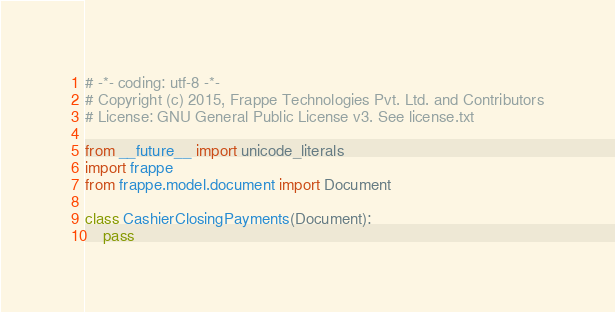Convert code to text. <code><loc_0><loc_0><loc_500><loc_500><_Python_># -*- coding: utf-8 -*-
# Copyright (c) 2015, Frappe Technologies Pvt. Ltd. and Contributors
# License: GNU General Public License v3. See license.txt

from __future__ import unicode_literals
import frappe
from frappe.model.document import Document

class CashierClosingPayments(Document):
	pass
</code> 